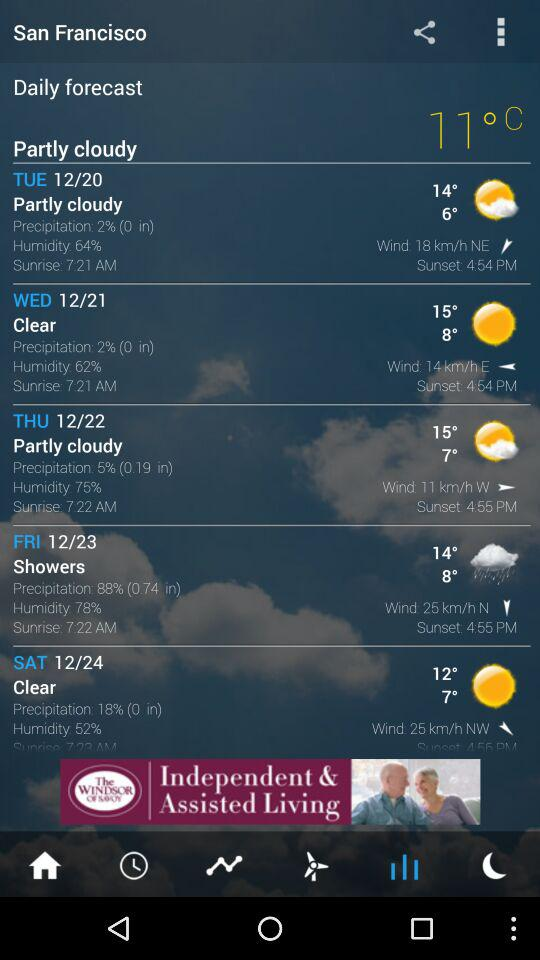How’s the weather? The weather is partly cloudy. 